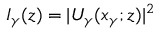<formula> <loc_0><loc_0><loc_500><loc_500>I _ { \gamma } ( z ) = | U _ { \gamma } ( x _ { \gamma } ; z ) | ^ { 2 }</formula> 